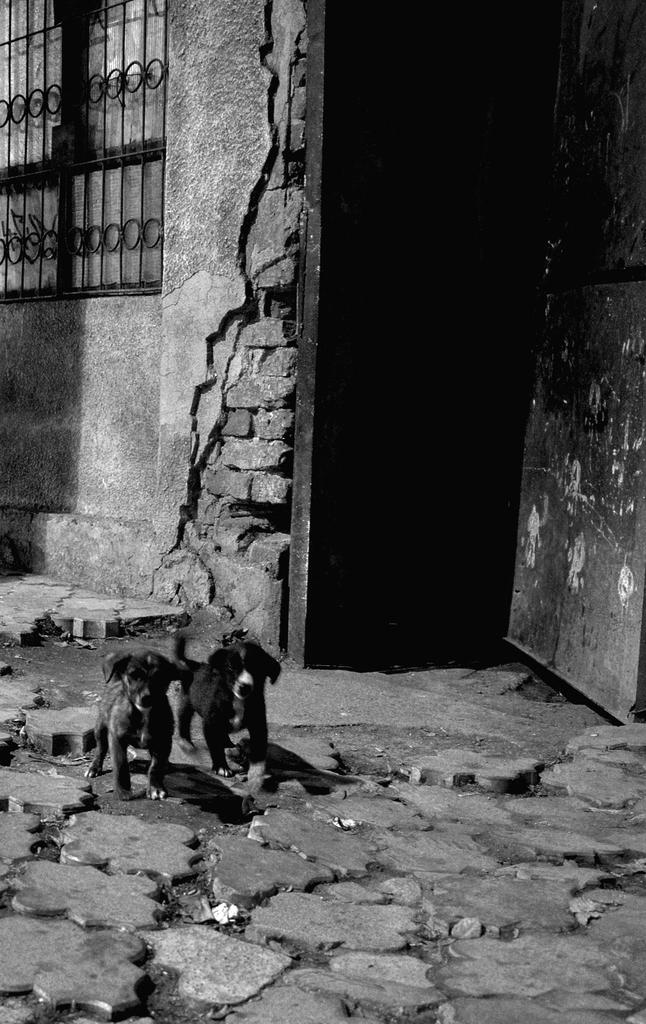How many animals are present in the image? There are two animals in the image. What can be seen in the image besides the animals? There is a railing and a wall in the image. What type of cork can be seen in the image? There is no cork present in the image. What is the animals' reaction to the joke in the image? The image does not depict a joke or any laughter, so it is not possible to determine the animals' reaction. 